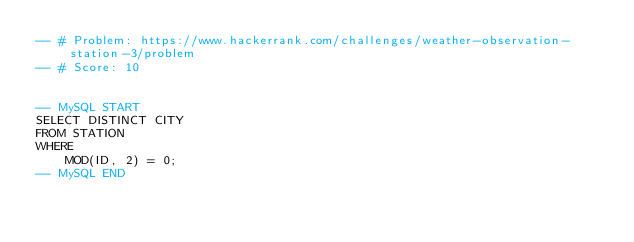Convert code to text. <code><loc_0><loc_0><loc_500><loc_500><_SQL_>-- # Problem: https://www.hackerrank.com/challenges/weather-observation-station-3/problem
-- # Score: 10


-- MySQL START
SELECT DISTINCT CITY
FROM STATION
WHERE
    MOD(ID, 2) = 0;
-- MySQL END
</code> 